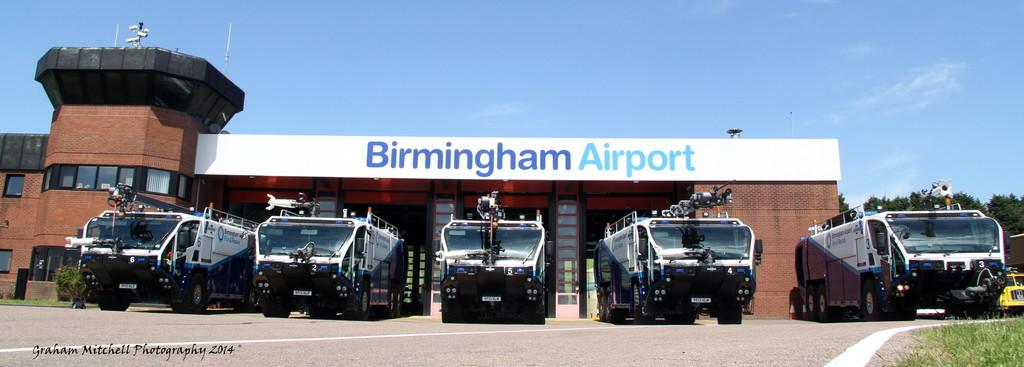What can be seen on the road in the image? There are vehicles on the road in the image. What type of structure is visible in the image? There is a building visible in the image. What is the color of the building? The building is in brown color. Can you describe the window in the image? There is a window in the image. What type of vegetation is present in the image? Trees are present in the image. What colors can be seen in the sky in the image? The sky is in white and blue color. What type of linen is draped over the vehicles in the image? There is no linen present in the image; it only shows vehicles on the road. What error can be seen in the building's construction in the image? There is no error visible in the building's construction in the image; it appears to be a normal brown building. How many chickens are visible in the image? There are no chickens present in the image. 